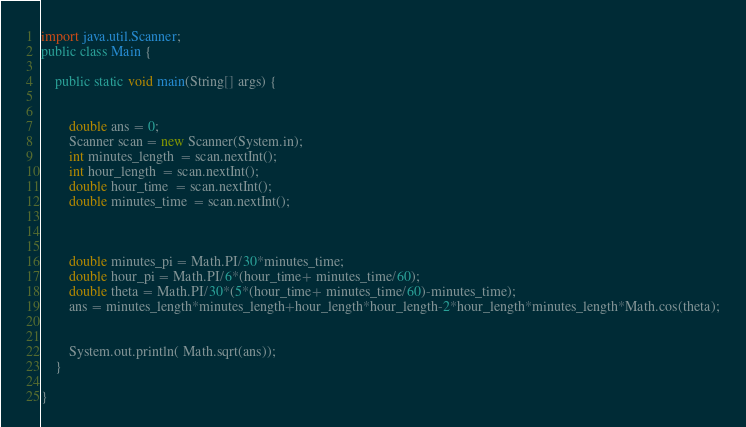<code> <loc_0><loc_0><loc_500><loc_500><_Java_>import java.util.Scanner;
public class Main {

	public static void main(String[] args) {


		double ans = 0;
		Scanner scan = new Scanner(System.in);
		int minutes_length  = scan.nextInt();
		int hour_length  = scan.nextInt();
		double hour_time  = scan.nextInt();
		double minutes_time  = scan.nextInt();



		double minutes_pi = Math.PI/30*minutes_time;
		double hour_pi = Math.PI/6*(hour_time+ minutes_time/60);
		double theta = Math.PI/30*(5*(hour_time+ minutes_time/60)-minutes_time);
		ans = minutes_length*minutes_length+hour_length*hour_length-2*hour_length*minutes_length*Math.cos(theta);


		System.out.println( Math.sqrt(ans));
	}

}</code> 